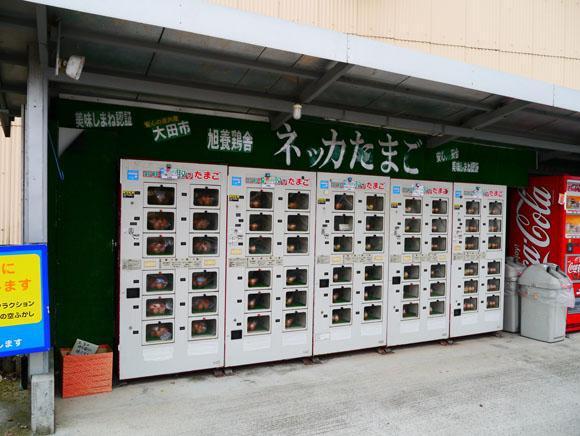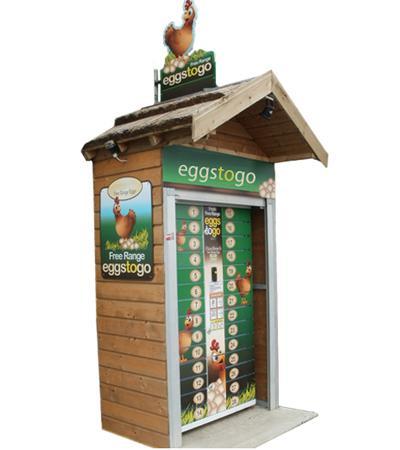The first image is the image on the left, the second image is the image on the right. Examine the images to the left and right. Is the description "There is at least one red vending machine in full view that accepts cash to dispense the food or drink." accurate? Answer yes or no. No. 